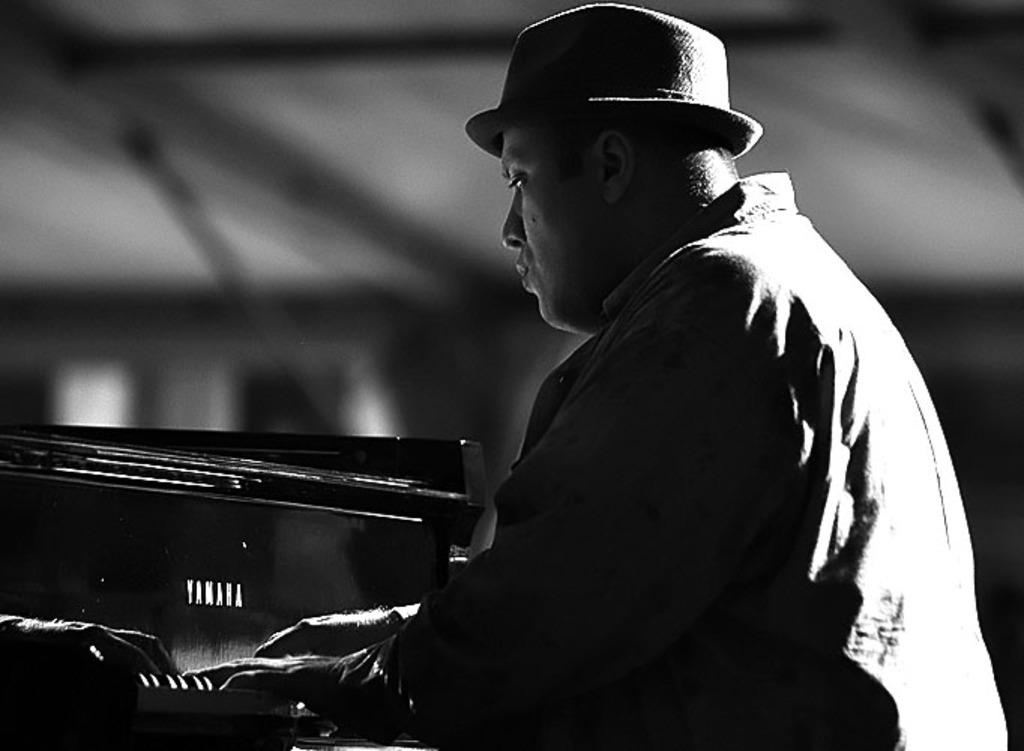What is the man in the image doing? The man is playing a piano. Where is the man located in relation to the piano? The man is sitting in front of the piano. What is the man wearing on his head? The man is wearing a hat. What is the condition of the roof in the image? There is no roof present in the image, as it features a man playing a piano. How many feet are visible in the image? There is no mention of feet in the provided facts, so it cannot be determined how many feet are visible. 